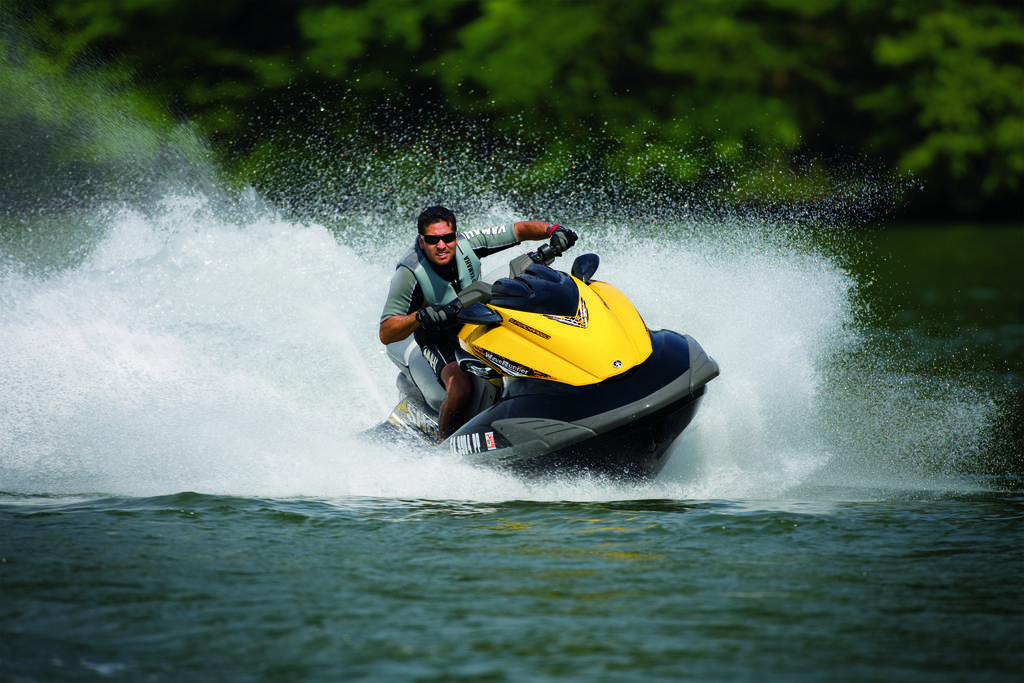Could you give a brief overview of what you see in this image? In this image we can see the person riding a jet ski on the water. And we can see the dark background. 